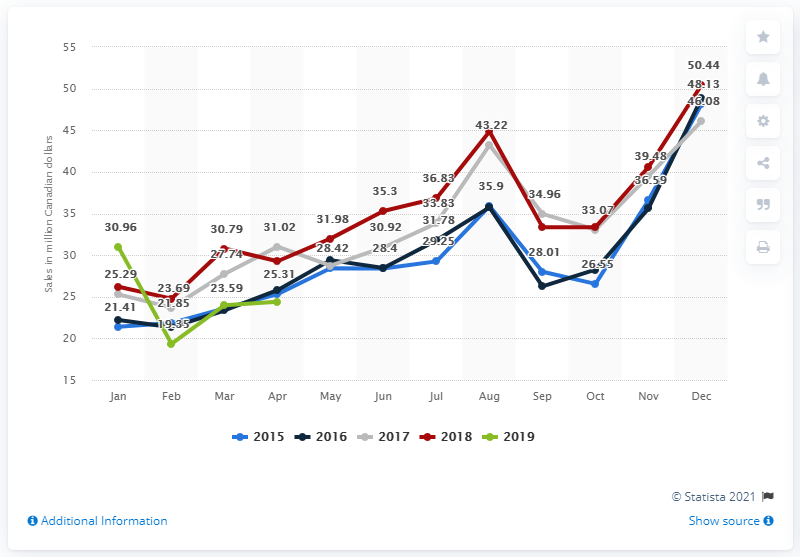Point out several critical features in this image. In April 2019, the retail sales of luggage at large retailers in Canada totaled 24.39. 